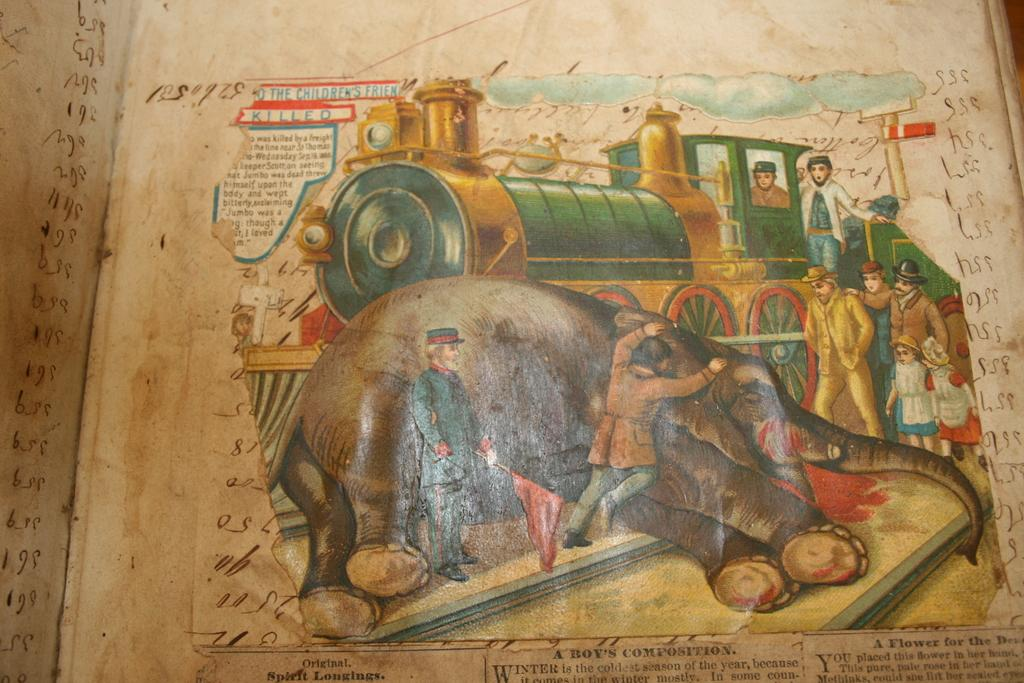<image>
Offer a succinct explanation of the picture presented. a train that has the children's friends written on it 